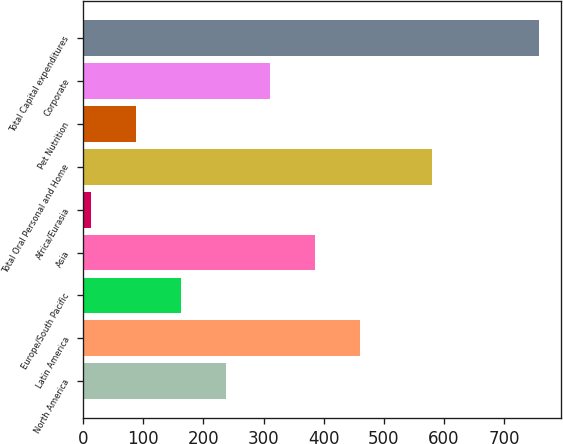<chart> <loc_0><loc_0><loc_500><loc_500><bar_chart><fcel>North America<fcel>Latin America<fcel>Europe/South Pacific<fcel>Asia<fcel>Africa/Eurasia<fcel>Total Oral Personal and Home<fcel>Pet Nutrition<fcel>Corporate<fcel>Total Capital expenditures<nl><fcel>236.9<fcel>459.8<fcel>162.6<fcel>385.5<fcel>14<fcel>580<fcel>88.3<fcel>311.2<fcel>757<nl></chart> 